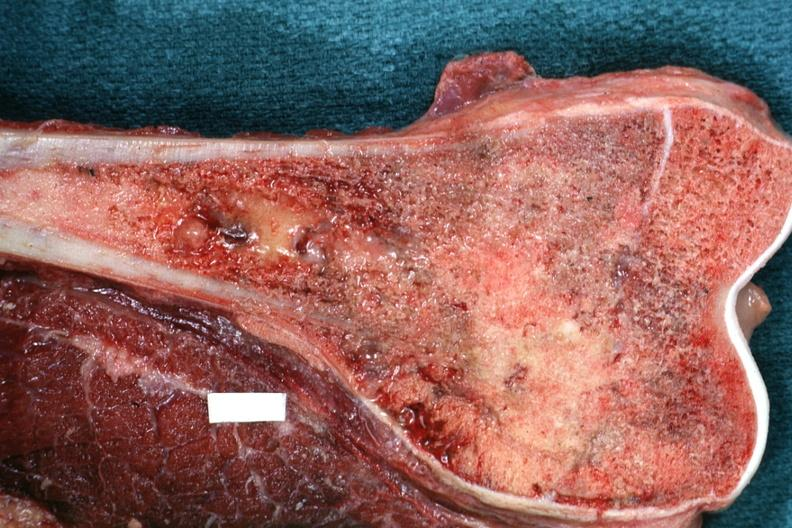s joints present?
Answer the question using a single word or phrase. Yes 